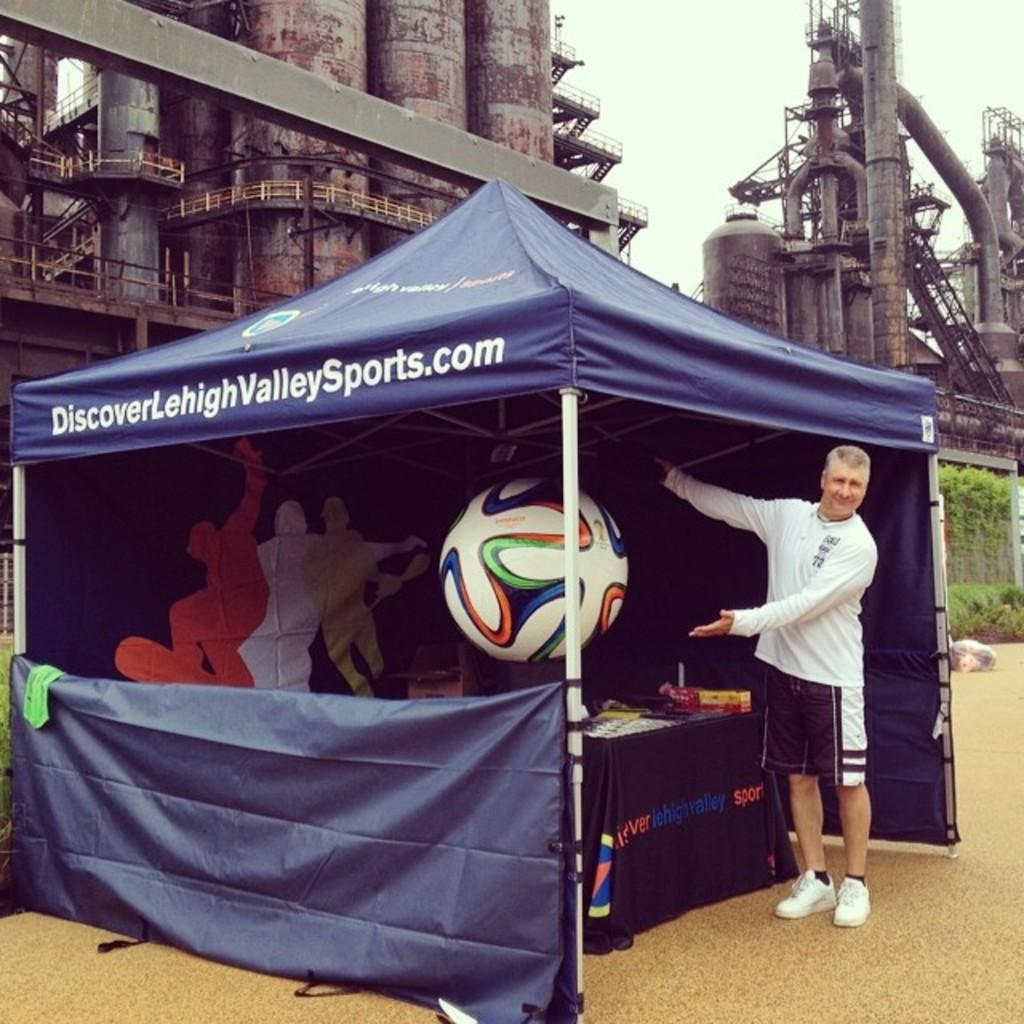What is the man doing in the image? The man is standing under a tent. What can be found inside the tent? There is a table inside the tent. What is on the table? There are objects placed on the table. What is visible in the background of the image? There is a factory visible at the back side of the image. What color is the sock on the man's tail in the image? There is no sock or tail present on the man in the image. 